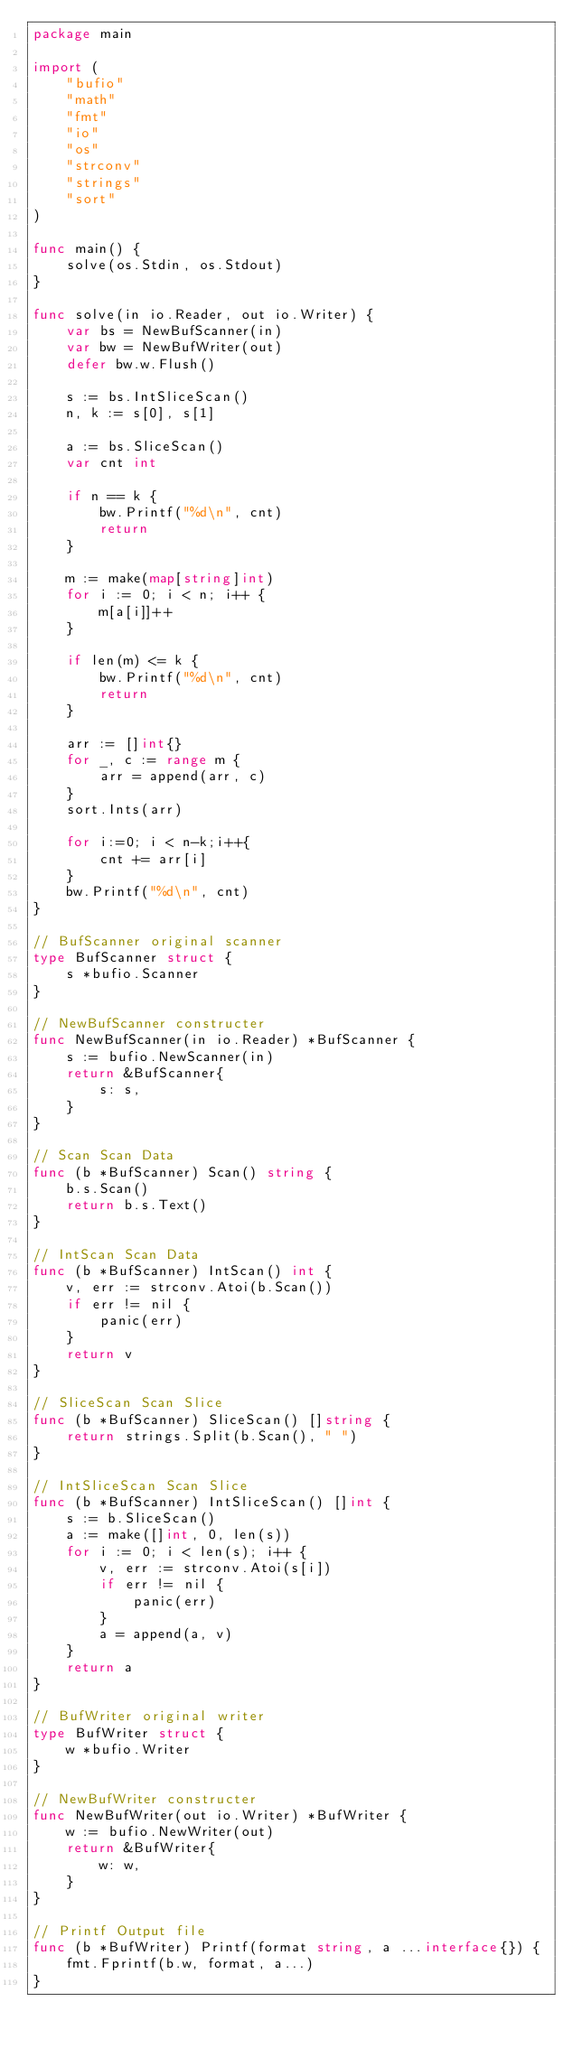Convert code to text. <code><loc_0><loc_0><loc_500><loc_500><_Go_>package main

import (
	"bufio"
	"math"
	"fmt"
	"io"
	"os"
	"strconv"
	"strings"
	"sort"
)

func main() {
	solve(os.Stdin, os.Stdout)
}

func solve(in io.Reader, out io.Writer) {
	var bs = NewBufScanner(in)
	var bw = NewBufWriter(out)
	defer bw.w.Flush()

	s := bs.IntSliceScan()
	n, k := s[0], s[1]

	a := bs.SliceScan()
	var cnt int

	if n == k {
		bw.Printf("%d\n", cnt)
		return
	}

	m := make(map[string]int)
	for i := 0; i < n; i++ {
		m[a[i]]++
	}

	if len(m) <= k {
		bw.Printf("%d\n", cnt)
		return
	}

	arr := []int{}
	for _, c := range m {
		arr = append(arr, c)
	}
	sort.Ints(arr)

	for i:=0; i < n-k;i++{
		cnt += arr[i]
	}
	bw.Printf("%d\n", cnt)
}

// BufScanner original scanner
type BufScanner struct {
	s *bufio.Scanner
}

// NewBufScanner constructer
func NewBufScanner(in io.Reader) *BufScanner {
	s := bufio.NewScanner(in)
	return &BufScanner{
		s: s,
	}
}

// Scan Scan Data
func (b *BufScanner) Scan() string {
	b.s.Scan()
	return b.s.Text()
}

// IntScan Scan Data
func (b *BufScanner) IntScan() int {
	v, err := strconv.Atoi(b.Scan())
	if err != nil {
		panic(err)
	}
	return v
}

// SliceScan Scan Slice
func (b *BufScanner) SliceScan() []string {
	return strings.Split(b.Scan(), " ")
}

// IntSliceScan Scan Slice
func (b *BufScanner) IntSliceScan() []int {
	s := b.SliceScan()
	a := make([]int, 0, len(s))
	for i := 0; i < len(s); i++ {
		v, err := strconv.Atoi(s[i])
		if err != nil {
			panic(err)
		}
		a = append(a, v)
	}
	return a
}

// BufWriter original writer
type BufWriter struct {
	w *bufio.Writer
}

// NewBufWriter constructer
func NewBufWriter(out io.Writer) *BufWriter {
	w := bufio.NewWriter(out)
	return &BufWriter{
		w: w,
	}
}

// Printf Output file
func (b *BufWriter) Printf(format string, a ...interface{}) {
	fmt.Fprintf(b.w, format, a...)
}</code> 